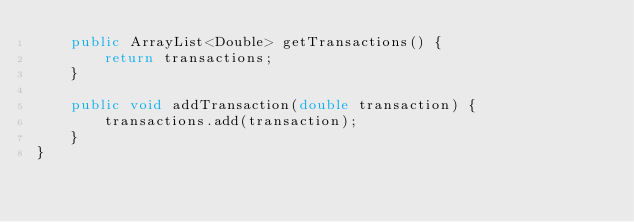Convert code to text. <code><loc_0><loc_0><loc_500><loc_500><_Java_>    public ArrayList<Double> getTransactions() {
        return transactions;
    }

    public void addTransaction(double transaction) {
        transactions.add(transaction);
    }
}
</code> 